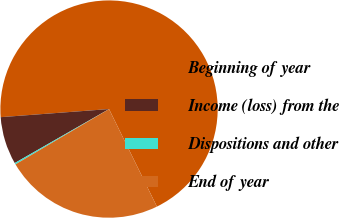Convert chart to OTSL. <chart><loc_0><loc_0><loc_500><loc_500><pie_chart><fcel>Beginning of year<fcel>Income (loss) from the<fcel>Dispositions and other<fcel>End of year<nl><fcel>68.93%<fcel>7.09%<fcel>0.22%<fcel>23.77%<nl></chart> 